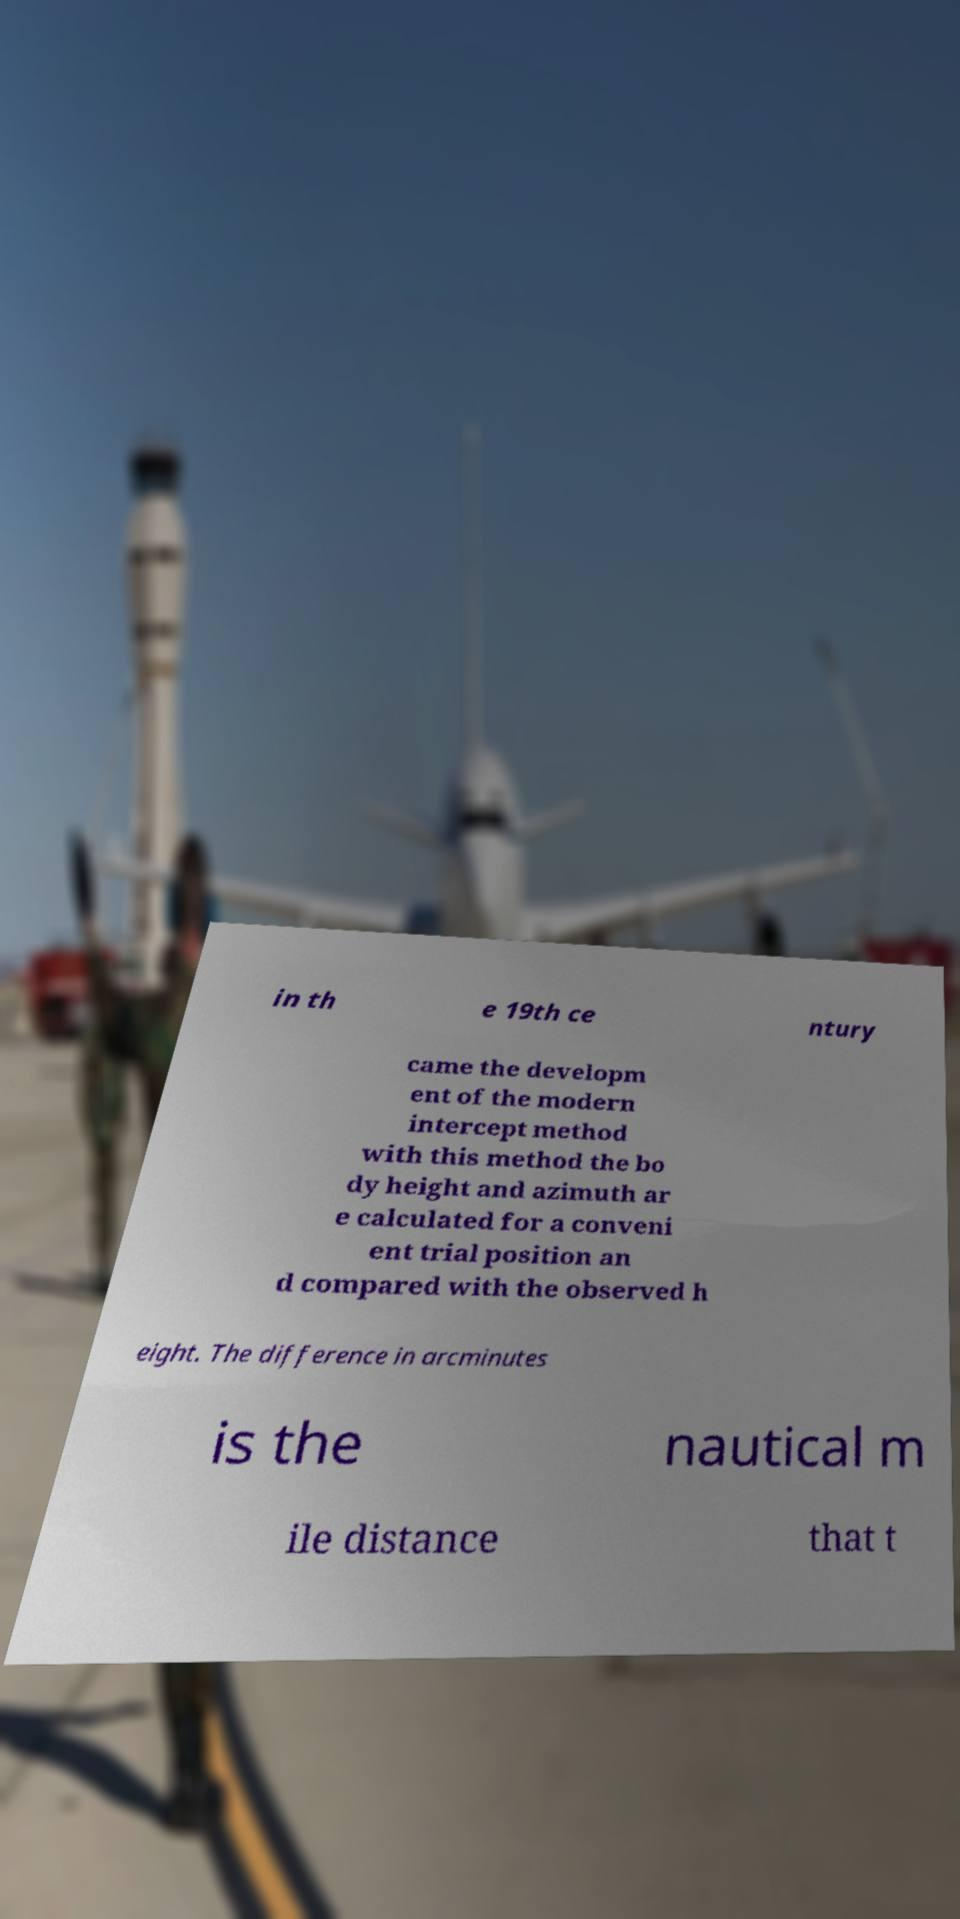What messages or text are displayed in this image? I need them in a readable, typed format. in th e 19th ce ntury came the developm ent of the modern intercept method with this method the bo dy height and azimuth ar e calculated for a conveni ent trial position an d compared with the observed h eight. The difference in arcminutes is the nautical m ile distance that t 